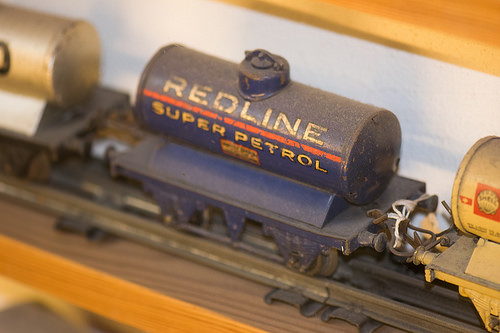<image>
Can you confirm if the train track is next to the train car? No. The train track is not positioned next to the train car. They are located in different areas of the scene. 